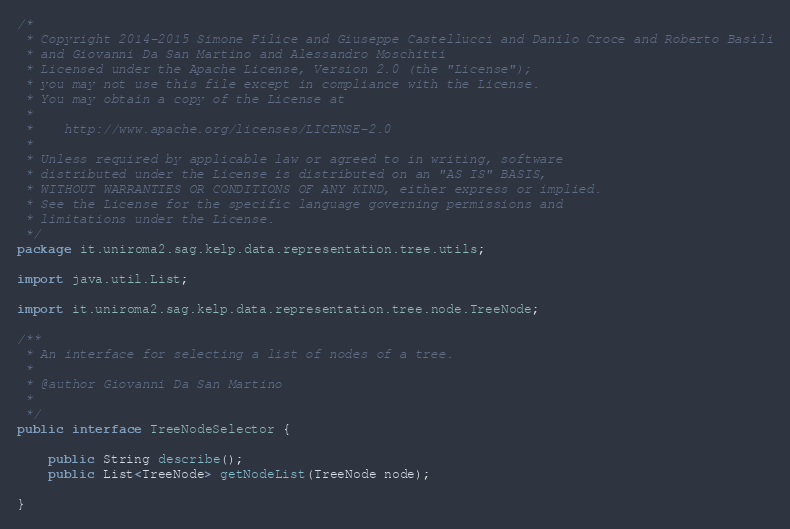Convert code to text. <code><loc_0><loc_0><loc_500><loc_500><_Java_>/*
 * Copyright 2014-2015 Simone Filice and Giuseppe Castellucci and Danilo Croce and Roberto Basili
 * and Giovanni Da San Martino and Alessandro Moschitti
 * Licensed under the Apache License, Version 2.0 (the "License");
 * you may not use this file except in compliance with the License.
 * You may obtain a copy of the License at
 *
 *    http://www.apache.org/licenses/LICENSE-2.0
 *
 * Unless required by applicable law or agreed to in writing, software
 * distributed under the License is distributed on an "AS IS" BASIS,
 * WITHOUT WARRANTIES OR CONDITIONS OF ANY KIND, either express or implied.
 * See the License for the specific language governing permissions and
 * limitations under the License.
 */
package it.uniroma2.sag.kelp.data.representation.tree.utils;

import java.util.List;

import it.uniroma2.sag.kelp.data.representation.tree.node.TreeNode;

/**
 * An interface for selecting a list of nodes of a tree.  
 * 
 * @author Giovanni Da San Martino
 *
 */
public interface TreeNodeSelector {

	public String describe();
	public List<TreeNode> getNodeList(TreeNode node); 
	
}
</code> 